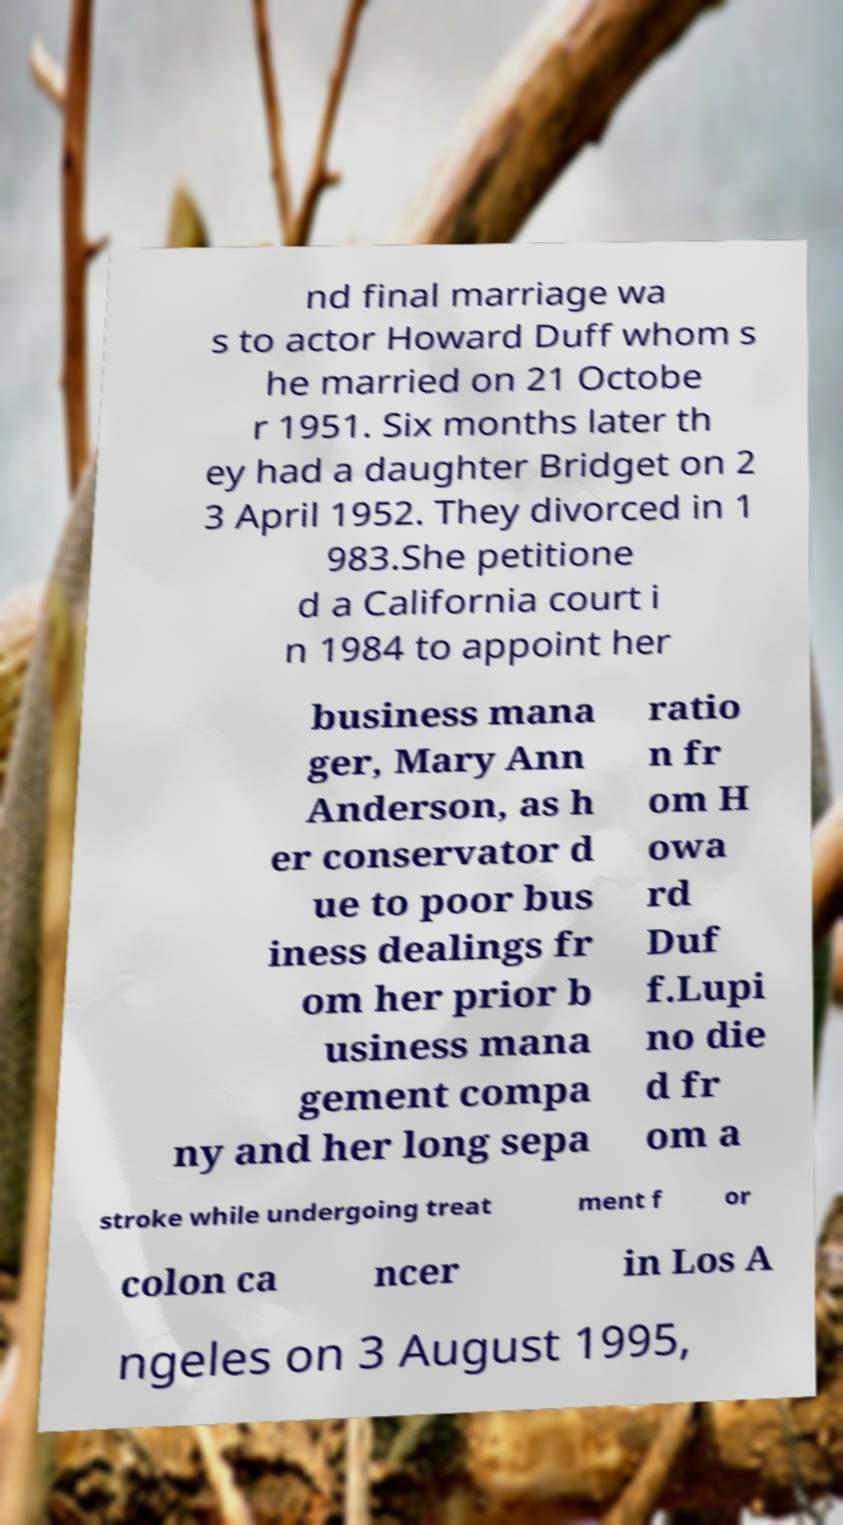Could you assist in decoding the text presented in this image and type it out clearly? nd final marriage wa s to actor Howard Duff whom s he married on 21 Octobe r 1951. Six months later th ey had a daughter Bridget on 2 3 April 1952. They divorced in 1 983.She petitione d a California court i n 1984 to appoint her business mana ger, Mary Ann Anderson, as h er conservator d ue to poor bus iness dealings fr om her prior b usiness mana gement compa ny and her long sepa ratio n fr om H owa rd Duf f.Lupi no die d fr om a stroke while undergoing treat ment f or colon ca ncer in Los A ngeles on 3 August 1995, 